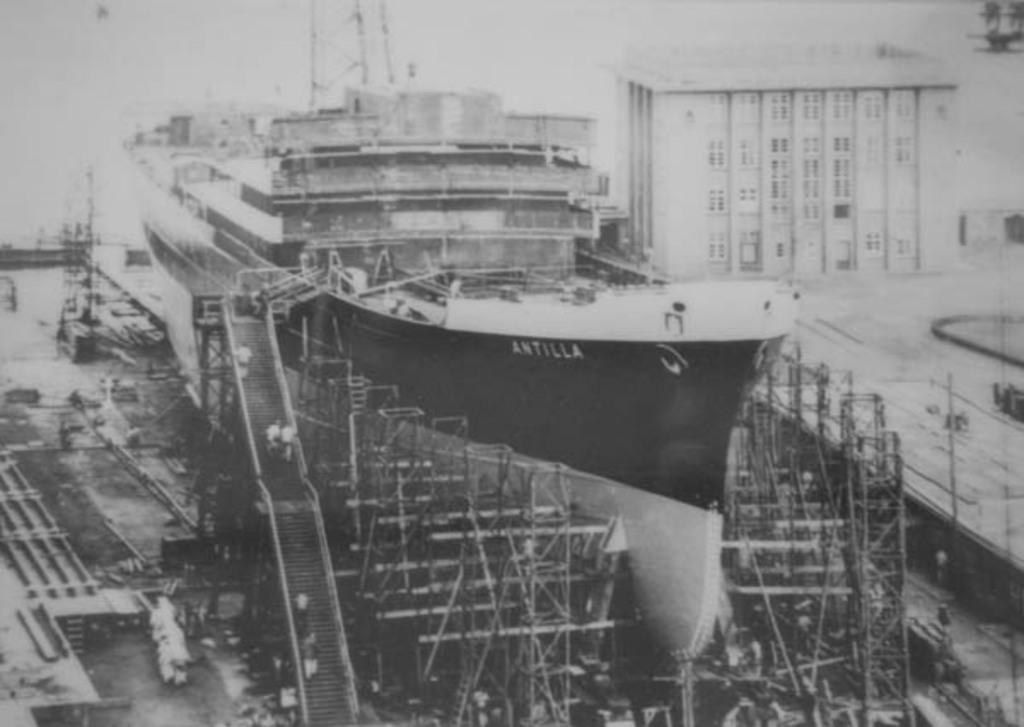Provide a one-sentence caption for the provided image. A huge ship under construction that says Antilla near the helm. 